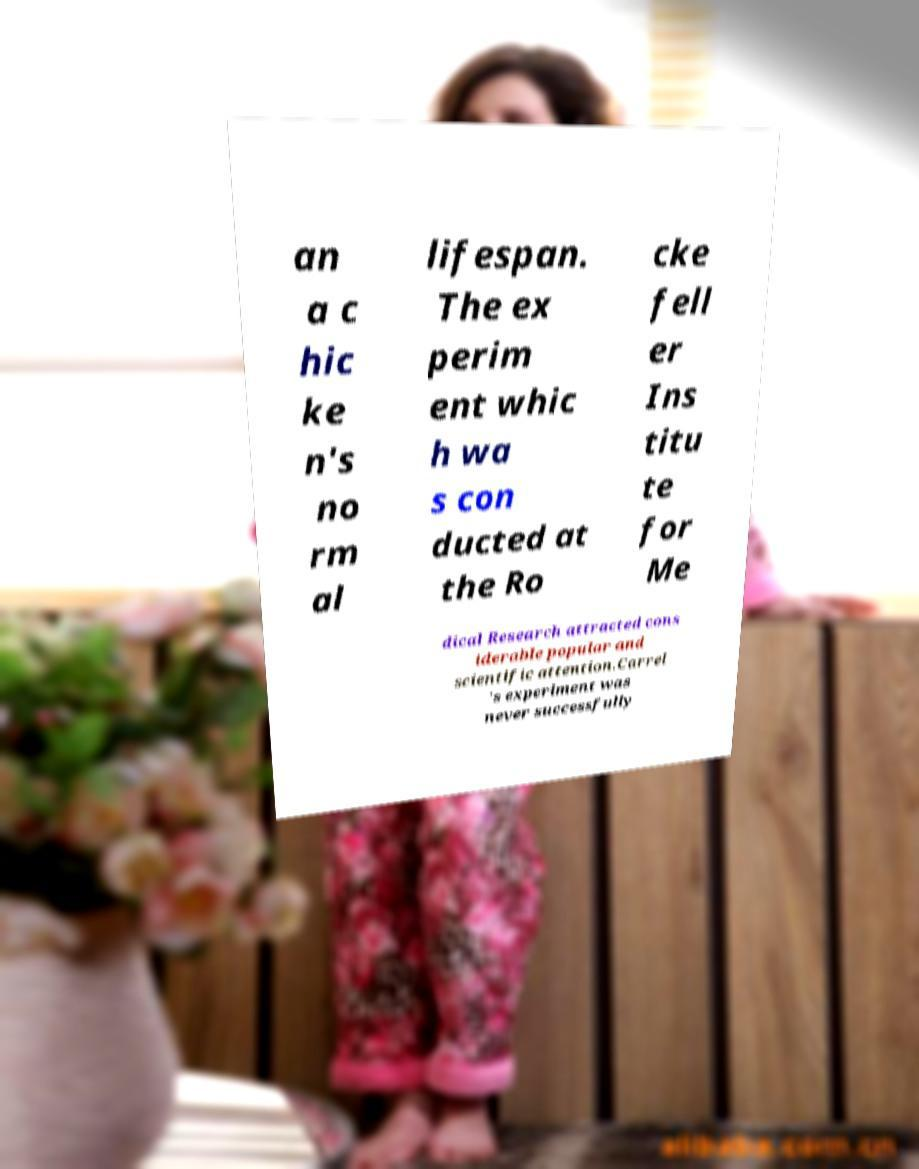For documentation purposes, I need the text within this image transcribed. Could you provide that? an a c hic ke n's no rm al lifespan. The ex perim ent whic h wa s con ducted at the Ro cke fell er Ins titu te for Me dical Research attracted cons iderable popular and scientific attention.Carrel 's experiment was never successfully 